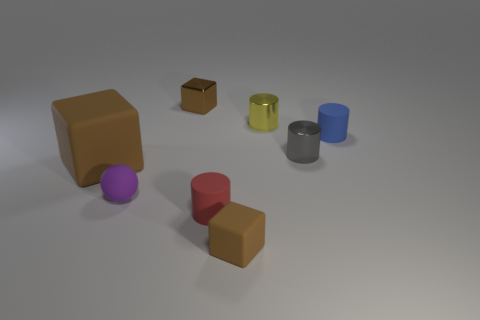There is a thing in front of the red cylinder; is it the same color as the small metal cube?
Ensure brevity in your answer.  Yes. There is a tiny rubber thing behind the thing that is left of the tiny purple object; is there a thing that is in front of it?
Your response must be concise. Yes. There is a brown metallic block; what number of red objects are left of it?
Ensure brevity in your answer.  0. What number of blocks are the same color as the large rubber thing?
Give a very brief answer. 2. What number of things are brown cubes that are behind the small gray metallic cylinder or rubber cylinders in front of the tiny purple thing?
Provide a short and direct response. 2. Are there more small brown rubber objects than tiny gray matte cylinders?
Give a very brief answer. Yes. There is a small metal thing in front of the tiny blue cylinder; what is its color?
Provide a succinct answer. Gray. Is the shape of the red object the same as the small gray object?
Offer a very short reply. Yes. There is a object that is behind the big brown block and left of the tiny yellow object; what is its color?
Make the answer very short. Brown. There is a block that is behind the tiny blue matte object; does it have the same size as the brown rubber thing right of the small brown metal thing?
Your answer should be very brief. Yes. 